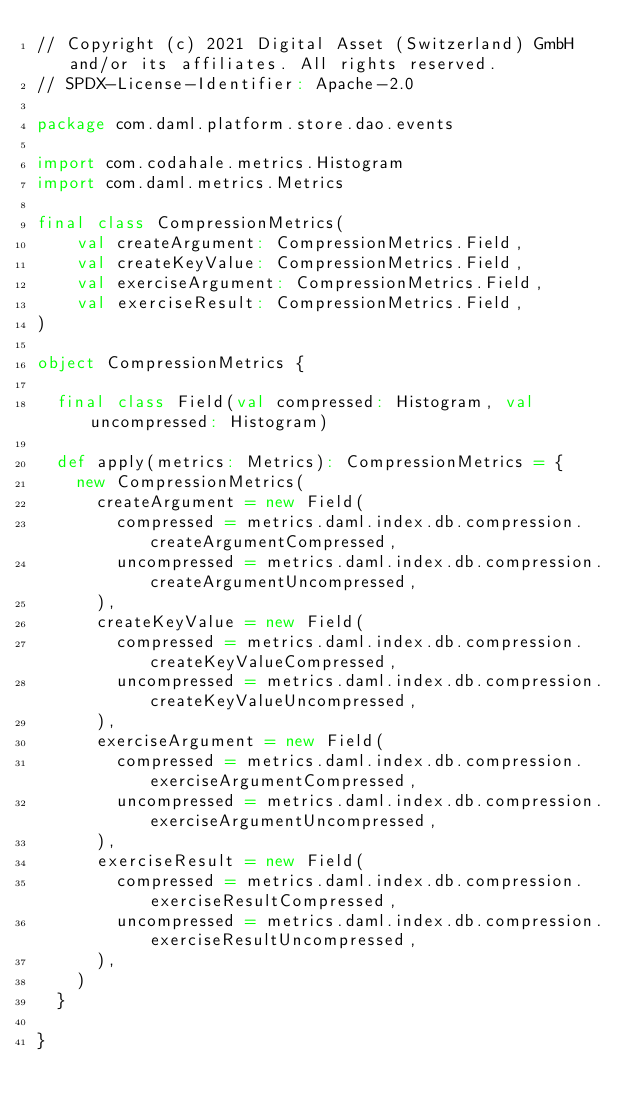Convert code to text. <code><loc_0><loc_0><loc_500><loc_500><_Scala_>// Copyright (c) 2021 Digital Asset (Switzerland) GmbH and/or its affiliates. All rights reserved.
// SPDX-License-Identifier: Apache-2.0

package com.daml.platform.store.dao.events

import com.codahale.metrics.Histogram
import com.daml.metrics.Metrics

final class CompressionMetrics(
    val createArgument: CompressionMetrics.Field,
    val createKeyValue: CompressionMetrics.Field,
    val exerciseArgument: CompressionMetrics.Field,
    val exerciseResult: CompressionMetrics.Field,
)

object CompressionMetrics {

  final class Field(val compressed: Histogram, val uncompressed: Histogram)

  def apply(metrics: Metrics): CompressionMetrics = {
    new CompressionMetrics(
      createArgument = new Field(
        compressed = metrics.daml.index.db.compression.createArgumentCompressed,
        uncompressed = metrics.daml.index.db.compression.createArgumentUncompressed,
      ),
      createKeyValue = new Field(
        compressed = metrics.daml.index.db.compression.createKeyValueCompressed,
        uncompressed = metrics.daml.index.db.compression.createKeyValueUncompressed,
      ),
      exerciseArgument = new Field(
        compressed = metrics.daml.index.db.compression.exerciseArgumentCompressed,
        uncompressed = metrics.daml.index.db.compression.exerciseArgumentUncompressed,
      ),
      exerciseResult = new Field(
        compressed = metrics.daml.index.db.compression.exerciseResultCompressed,
        uncompressed = metrics.daml.index.db.compression.exerciseResultUncompressed,
      ),
    )
  }

}
</code> 